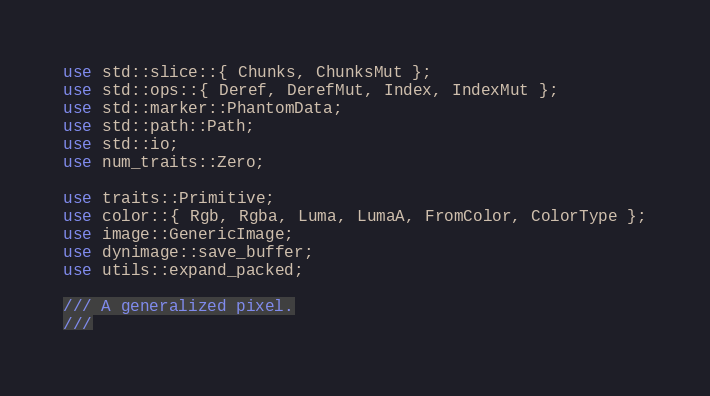<code> <loc_0><loc_0><loc_500><loc_500><_Rust_>use std::slice::{ Chunks, ChunksMut };
use std::ops::{ Deref, DerefMut, Index, IndexMut };
use std::marker::PhantomData;
use std::path::Path;
use std::io;
use num_traits::Zero;

use traits::Primitive;
use color::{ Rgb, Rgba, Luma, LumaA, FromColor, ColorType };
use image::GenericImage;
use dynimage::save_buffer;
use utils::expand_packed;

/// A generalized pixel.
///</code> 